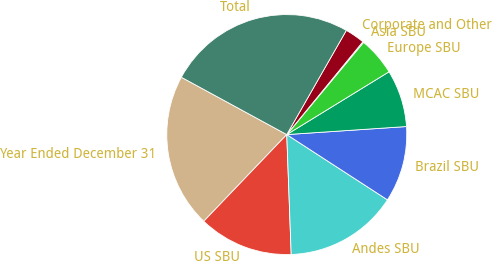Convert chart. <chart><loc_0><loc_0><loc_500><loc_500><pie_chart><fcel>Year Ended December 31<fcel>US SBU<fcel>Andes SBU<fcel>Brazil SBU<fcel>MCAC SBU<fcel>Europe SBU<fcel>Asia SBU<fcel>Corporate and Other<fcel>Total<nl><fcel>20.78%<fcel>12.74%<fcel>15.26%<fcel>10.22%<fcel>7.7%<fcel>5.18%<fcel>0.13%<fcel>2.66%<fcel>25.34%<nl></chart> 